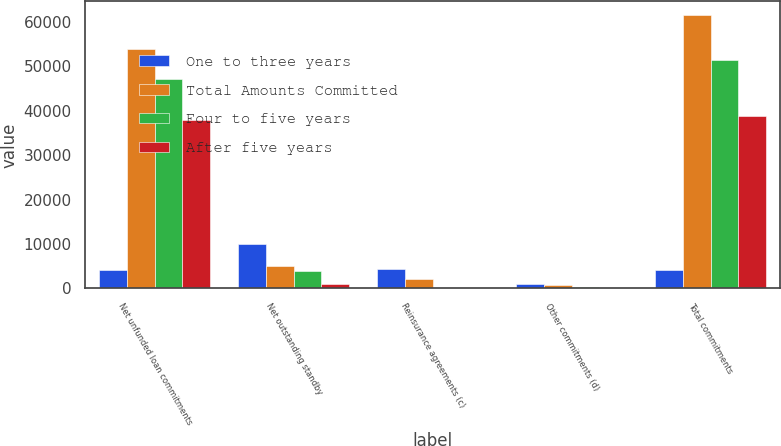Convert chart. <chart><loc_0><loc_0><loc_500><loc_500><stacked_bar_chart><ecel><fcel>Net unfunded loan commitments<fcel>Net outstanding standby<fcel>Reinsurance agreements (c)<fcel>Other commitments (d)<fcel>Total commitments<nl><fcel>One to three years<fcel>4192.5<fcel>9991<fcel>4342<fcel>962<fcel>4192.5<nl><fcel>Total Amounts Committed<fcel>53849<fcel>4973<fcel>2071<fcel>693<fcel>61586<nl><fcel>Four to five years<fcel>47180<fcel>4043<fcel>20<fcel>236<fcel>51479<nl><fcel>After five years<fcel>37873<fcel>973<fcel>36<fcel>32<fcel>38914<nl></chart> 